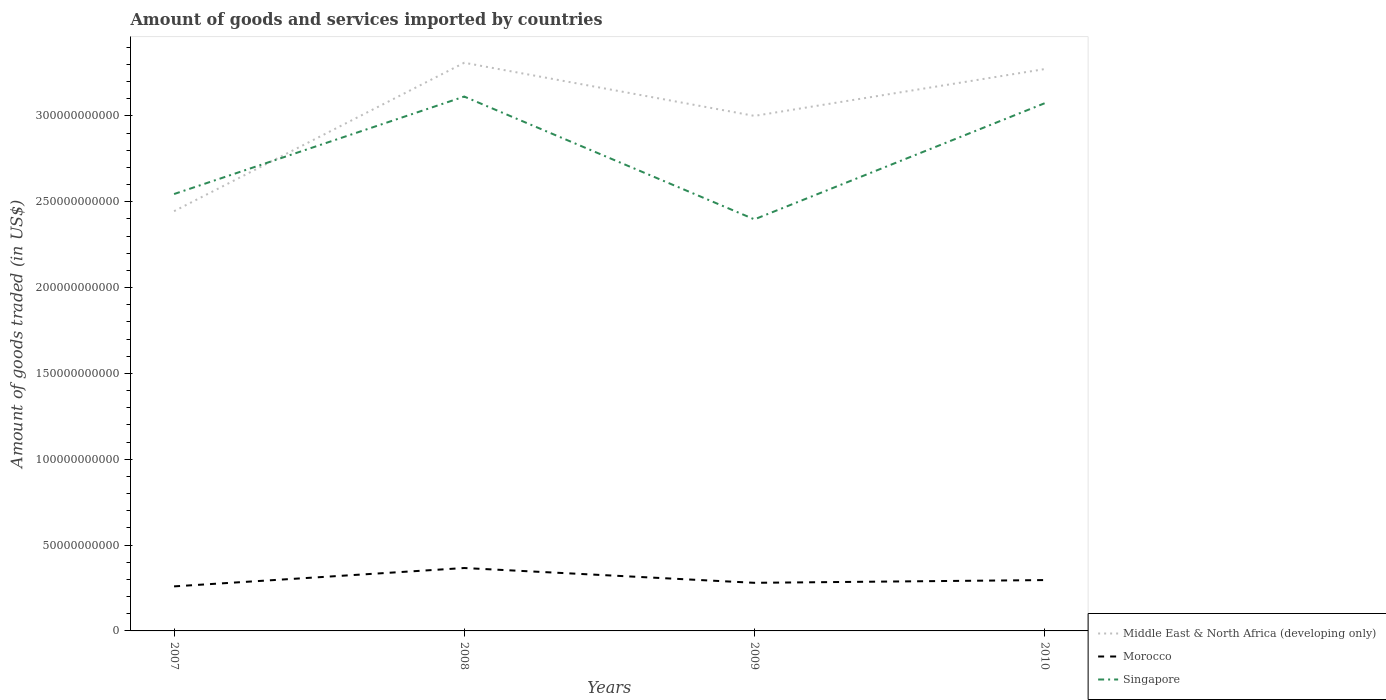How many different coloured lines are there?
Your answer should be compact. 3. Does the line corresponding to Singapore intersect with the line corresponding to Middle East & North Africa (developing only)?
Offer a very short reply. Yes. Across all years, what is the maximum total amount of goods and services imported in Singapore?
Ensure brevity in your answer.  2.40e+11. What is the total total amount of goods and services imported in Singapore in the graph?
Give a very brief answer. 3.91e+09. What is the difference between the highest and the second highest total amount of goods and services imported in Morocco?
Make the answer very short. 1.07e+1. What is the difference between two consecutive major ticks on the Y-axis?
Ensure brevity in your answer.  5.00e+1. Does the graph contain any zero values?
Offer a very short reply. No. Does the graph contain grids?
Your answer should be very brief. No. Where does the legend appear in the graph?
Keep it short and to the point. Bottom right. How many legend labels are there?
Provide a short and direct response. 3. What is the title of the graph?
Offer a very short reply. Amount of goods and services imported by countries. What is the label or title of the Y-axis?
Your response must be concise. Amount of goods traded (in US$). What is the Amount of goods traded (in US$) of Middle East & North Africa (developing only) in 2007?
Offer a very short reply. 2.45e+11. What is the Amount of goods traded (in US$) of Morocco in 2007?
Offer a very short reply. 2.60e+1. What is the Amount of goods traded (in US$) of Singapore in 2007?
Ensure brevity in your answer.  2.55e+11. What is the Amount of goods traded (in US$) in Middle East & North Africa (developing only) in 2008?
Give a very brief answer. 3.31e+11. What is the Amount of goods traded (in US$) in Morocco in 2008?
Your answer should be very brief. 3.67e+1. What is the Amount of goods traded (in US$) of Singapore in 2008?
Ensure brevity in your answer.  3.11e+11. What is the Amount of goods traded (in US$) of Middle East & North Africa (developing only) in 2009?
Keep it short and to the point. 3.00e+11. What is the Amount of goods traded (in US$) of Morocco in 2009?
Keep it short and to the point. 2.80e+1. What is the Amount of goods traded (in US$) in Singapore in 2009?
Provide a succinct answer. 2.40e+11. What is the Amount of goods traded (in US$) in Middle East & North Africa (developing only) in 2010?
Provide a short and direct response. 3.27e+11. What is the Amount of goods traded (in US$) of Morocco in 2010?
Make the answer very short. 2.96e+1. What is the Amount of goods traded (in US$) of Singapore in 2010?
Offer a very short reply. 3.07e+11. Across all years, what is the maximum Amount of goods traded (in US$) of Middle East & North Africa (developing only)?
Provide a succinct answer. 3.31e+11. Across all years, what is the maximum Amount of goods traded (in US$) of Morocco?
Your response must be concise. 3.67e+1. Across all years, what is the maximum Amount of goods traded (in US$) of Singapore?
Your answer should be compact. 3.11e+11. Across all years, what is the minimum Amount of goods traded (in US$) of Middle East & North Africa (developing only)?
Offer a terse response. 2.45e+11. Across all years, what is the minimum Amount of goods traded (in US$) in Morocco?
Your answer should be very brief. 2.60e+1. Across all years, what is the minimum Amount of goods traded (in US$) in Singapore?
Your answer should be very brief. 2.40e+11. What is the total Amount of goods traded (in US$) in Middle East & North Africa (developing only) in the graph?
Provide a short and direct response. 1.20e+12. What is the total Amount of goods traded (in US$) of Morocco in the graph?
Offer a very short reply. 1.20e+11. What is the total Amount of goods traded (in US$) in Singapore in the graph?
Offer a terse response. 1.11e+12. What is the difference between the Amount of goods traded (in US$) of Middle East & North Africa (developing only) in 2007 and that in 2008?
Your answer should be compact. -8.65e+1. What is the difference between the Amount of goods traded (in US$) in Morocco in 2007 and that in 2008?
Provide a succinct answer. -1.07e+1. What is the difference between the Amount of goods traded (in US$) in Singapore in 2007 and that in 2008?
Your answer should be compact. -5.68e+1. What is the difference between the Amount of goods traded (in US$) in Middle East & North Africa (developing only) in 2007 and that in 2009?
Your answer should be compact. -5.55e+1. What is the difference between the Amount of goods traded (in US$) in Morocco in 2007 and that in 2009?
Ensure brevity in your answer.  -2.07e+09. What is the difference between the Amount of goods traded (in US$) in Singapore in 2007 and that in 2009?
Your answer should be compact. 1.48e+1. What is the difference between the Amount of goods traded (in US$) of Middle East & North Africa (developing only) in 2007 and that in 2010?
Offer a very short reply. -8.28e+1. What is the difference between the Amount of goods traded (in US$) of Morocco in 2007 and that in 2010?
Give a very brief answer. -3.67e+09. What is the difference between the Amount of goods traded (in US$) in Singapore in 2007 and that in 2010?
Ensure brevity in your answer.  -5.29e+1. What is the difference between the Amount of goods traded (in US$) in Middle East & North Africa (developing only) in 2008 and that in 2009?
Your answer should be compact. 3.10e+1. What is the difference between the Amount of goods traded (in US$) of Morocco in 2008 and that in 2009?
Ensure brevity in your answer.  8.62e+09. What is the difference between the Amount of goods traded (in US$) in Singapore in 2008 and that in 2009?
Provide a short and direct response. 7.15e+1. What is the difference between the Amount of goods traded (in US$) of Middle East & North Africa (developing only) in 2008 and that in 2010?
Offer a terse response. 3.69e+09. What is the difference between the Amount of goods traded (in US$) in Morocco in 2008 and that in 2010?
Provide a short and direct response. 7.02e+09. What is the difference between the Amount of goods traded (in US$) in Singapore in 2008 and that in 2010?
Keep it short and to the point. 3.91e+09. What is the difference between the Amount of goods traded (in US$) of Middle East & North Africa (developing only) in 2009 and that in 2010?
Keep it short and to the point. -2.73e+1. What is the difference between the Amount of goods traded (in US$) of Morocco in 2009 and that in 2010?
Give a very brief answer. -1.60e+09. What is the difference between the Amount of goods traded (in US$) in Singapore in 2009 and that in 2010?
Your response must be concise. -6.76e+1. What is the difference between the Amount of goods traded (in US$) in Middle East & North Africa (developing only) in 2007 and the Amount of goods traded (in US$) in Morocco in 2008?
Offer a very short reply. 2.08e+11. What is the difference between the Amount of goods traded (in US$) of Middle East & North Africa (developing only) in 2007 and the Amount of goods traded (in US$) of Singapore in 2008?
Provide a short and direct response. -6.68e+1. What is the difference between the Amount of goods traded (in US$) in Morocco in 2007 and the Amount of goods traded (in US$) in Singapore in 2008?
Offer a terse response. -2.85e+11. What is the difference between the Amount of goods traded (in US$) of Middle East & North Africa (developing only) in 2007 and the Amount of goods traded (in US$) of Morocco in 2009?
Provide a succinct answer. 2.17e+11. What is the difference between the Amount of goods traded (in US$) of Middle East & North Africa (developing only) in 2007 and the Amount of goods traded (in US$) of Singapore in 2009?
Offer a very short reply. 4.76e+09. What is the difference between the Amount of goods traded (in US$) in Morocco in 2007 and the Amount of goods traded (in US$) in Singapore in 2009?
Provide a short and direct response. -2.14e+11. What is the difference between the Amount of goods traded (in US$) in Middle East & North Africa (developing only) in 2007 and the Amount of goods traded (in US$) in Morocco in 2010?
Offer a very short reply. 2.15e+11. What is the difference between the Amount of goods traded (in US$) in Middle East & North Africa (developing only) in 2007 and the Amount of goods traded (in US$) in Singapore in 2010?
Ensure brevity in your answer.  -6.29e+1. What is the difference between the Amount of goods traded (in US$) of Morocco in 2007 and the Amount of goods traded (in US$) of Singapore in 2010?
Offer a very short reply. -2.81e+11. What is the difference between the Amount of goods traded (in US$) of Middle East & North Africa (developing only) in 2008 and the Amount of goods traded (in US$) of Morocco in 2009?
Provide a short and direct response. 3.03e+11. What is the difference between the Amount of goods traded (in US$) in Middle East & North Africa (developing only) in 2008 and the Amount of goods traded (in US$) in Singapore in 2009?
Give a very brief answer. 9.12e+1. What is the difference between the Amount of goods traded (in US$) in Morocco in 2008 and the Amount of goods traded (in US$) in Singapore in 2009?
Give a very brief answer. -2.03e+11. What is the difference between the Amount of goods traded (in US$) of Middle East & North Africa (developing only) in 2008 and the Amount of goods traded (in US$) of Morocco in 2010?
Your answer should be very brief. 3.01e+11. What is the difference between the Amount of goods traded (in US$) of Middle East & North Africa (developing only) in 2008 and the Amount of goods traded (in US$) of Singapore in 2010?
Ensure brevity in your answer.  2.36e+1. What is the difference between the Amount of goods traded (in US$) of Morocco in 2008 and the Amount of goods traded (in US$) of Singapore in 2010?
Provide a succinct answer. -2.71e+11. What is the difference between the Amount of goods traded (in US$) of Middle East & North Africa (developing only) in 2009 and the Amount of goods traded (in US$) of Morocco in 2010?
Give a very brief answer. 2.70e+11. What is the difference between the Amount of goods traded (in US$) of Middle East & North Africa (developing only) in 2009 and the Amount of goods traded (in US$) of Singapore in 2010?
Ensure brevity in your answer.  -7.35e+09. What is the difference between the Amount of goods traded (in US$) in Morocco in 2009 and the Amount of goods traded (in US$) in Singapore in 2010?
Provide a succinct answer. -2.79e+11. What is the average Amount of goods traded (in US$) of Middle East & North Africa (developing only) per year?
Keep it short and to the point. 3.01e+11. What is the average Amount of goods traded (in US$) of Morocco per year?
Provide a short and direct response. 3.01e+1. What is the average Amount of goods traded (in US$) of Singapore per year?
Provide a short and direct response. 2.78e+11. In the year 2007, what is the difference between the Amount of goods traded (in US$) in Middle East & North Africa (developing only) and Amount of goods traded (in US$) in Morocco?
Your response must be concise. 2.19e+11. In the year 2007, what is the difference between the Amount of goods traded (in US$) in Middle East & North Africa (developing only) and Amount of goods traded (in US$) in Singapore?
Keep it short and to the point. -9.99e+09. In the year 2007, what is the difference between the Amount of goods traded (in US$) in Morocco and Amount of goods traded (in US$) in Singapore?
Offer a terse response. -2.29e+11. In the year 2008, what is the difference between the Amount of goods traded (in US$) of Middle East & North Africa (developing only) and Amount of goods traded (in US$) of Morocco?
Keep it short and to the point. 2.94e+11. In the year 2008, what is the difference between the Amount of goods traded (in US$) of Middle East & North Africa (developing only) and Amount of goods traded (in US$) of Singapore?
Provide a short and direct response. 1.97e+1. In the year 2008, what is the difference between the Amount of goods traded (in US$) in Morocco and Amount of goods traded (in US$) in Singapore?
Offer a very short reply. -2.75e+11. In the year 2009, what is the difference between the Amount of goods traded (in US$) in Middle East & North Africa (developing only) and Amount of goods traded (in US$) in Morocco?
Keep it short and to the point. 2.72e+11. In the year 2009, what is the difference between the Amount of goods traded (in US$) in Middle East & North Africa (developing only) and Amount of goods traded (in US$) in Singapore?
Your answer should be compact. 6.03e+1. In the year 2009, what is the difference between the Amount of goods traded (in US$) in Morocco and Amount of goods traded (in US$) in Singapore?
Provide a succinct answer. -2.12e+11. In the year 2010, what is the difference between the Amount of goods traded (in US$) of Middle East & North Africa (developing only) and Amount of goods traded (in US$) of Morocco?
Your answer should be very brief. 2.98e+11. In the year 2010, what is the difference between the Amount of goods traded (in US$) in Middle East & North Africa (developing only) and Amount of goods traded (in US$) in Singapore?
Offer a very short reply. 1.99e+1. In the year 2010, what is the difference between the Amount of goods traded (in US$) in Morocco and Amount of goods traded (in US$) in Singapore?
Give a very brief answer. -2.78e+11. What is the ratio of the Amount of goods traded (in US$) of Middle East & North Africa (developing only) in 2007 to that in 2008?
Your answer should be compact. 0.74. What is the ratio of the Amount of goods traded (in US$) in Morocco in 2007 to that in 2008?
Give a very brief answer. 0.71. What is the ratio of the Amount of goods traded (in US$) in Singapore in 2007 to that in 2008?
Your answer should be very brief. 0.82. What is the ratio of the Amount of goods traded (in US$) of Middle East & North Africa (developing only) in 2007 to that in 2009?
Provide a succinct answer. 0.81. What is the ratio of the Amount of goods traded (in US$) in Morocco in 2007 to that in 2009?
Offer a terse response. 0.93. What is the ratio of the Amount of goods traded (in US$) in Singapore in 2007 to that in 2009?
Provide a succinct answer. 1.06. What is the ratio of the Amount of goods traded (in US$) of Middle East & North Africa (developing only) in 2007 to that in 2010?
Give a very brief answer. 0.75. What is the ratio of the Amount of goods traded (in US$) in Morocco in 2007 to that in 2010?
Provide a succinct answer. 0.88. What is the ratio of the Amount of goods traded (in US$) of Singapore in 2007 to that in 2010?
Provide a succinct answer. 0.83. What is the ratio of the Amount of goods traded (in US$) in Middle East & North Africa (developing only) in 2008 to that in 2009?
Offer a terse response. 1.1. What is the ratio of the Amount of goods traded (in US$) in Morocco in 2008 to that in 2009?
Keep it short and to the point. 1.31. What is the ratio of the Amount of goods traded (in US$) in Singapore in 2008 to that in 2009?
Offer a very short reply. 1.3. What is the ratio of the Amount of goods traded (in US$) in Middle East & North Africa (developing only) in 2008 to that in 2010?
Make the answer very short. 1.01. What is the ratio of the Amount of goods traded (in US$) in Morocco in 2008 to that in 2010?
Make the answer very short. 1.24. What is the ratio of the Amount of goods traded (in US$) of Singapore in 2008 to that in 2010?
Your response must be concise. 1.01. What is the ratio of the Amount of goods traded (in US$) in Middle East & North Africa (developing only) in 2009 to that in 2010?
Your response must be concise. 0.92. What is the ratio of the Amount of goods traded (in US$) of Morocco in 2009 to that in 2010?
Your answer should be very brief. 0.95. What is the ratio of the Amount of goods traded (in US$) of Singapore in 2009 to that in 2010?
Provide a succinct answer. 0.78. What is the difference between the highest and the second highest Amount of goods traded (in US$) in Middle East & North Africa (developing only)?
Provide a short and direct response. 3.69e+09. What is the difference between the highest and the second highest Amount of goods traded (in US$) in Morocco?
Provide a succinct answer. 7.02e+09. What is the difference between the highest and the second highest Amount of goods traded (in US$) of Singapore?
Provide a short and direct response. 3.91e+09. What is the difference between the highest and the lowest Amount of goods traded (in US$) in Middle East & North Africa (developing only)?
Make the answer very short. 8.65e+1. What is the difference between the highest and the lowest Amount of goods traded (in US$) of Morocco?
Offer a terse response. 1.07e+1. What is the difference between the highest and the lowest Amount of goods traded (in US$) in Singapore?
Your answer should be very brief. 7.15e+1. 